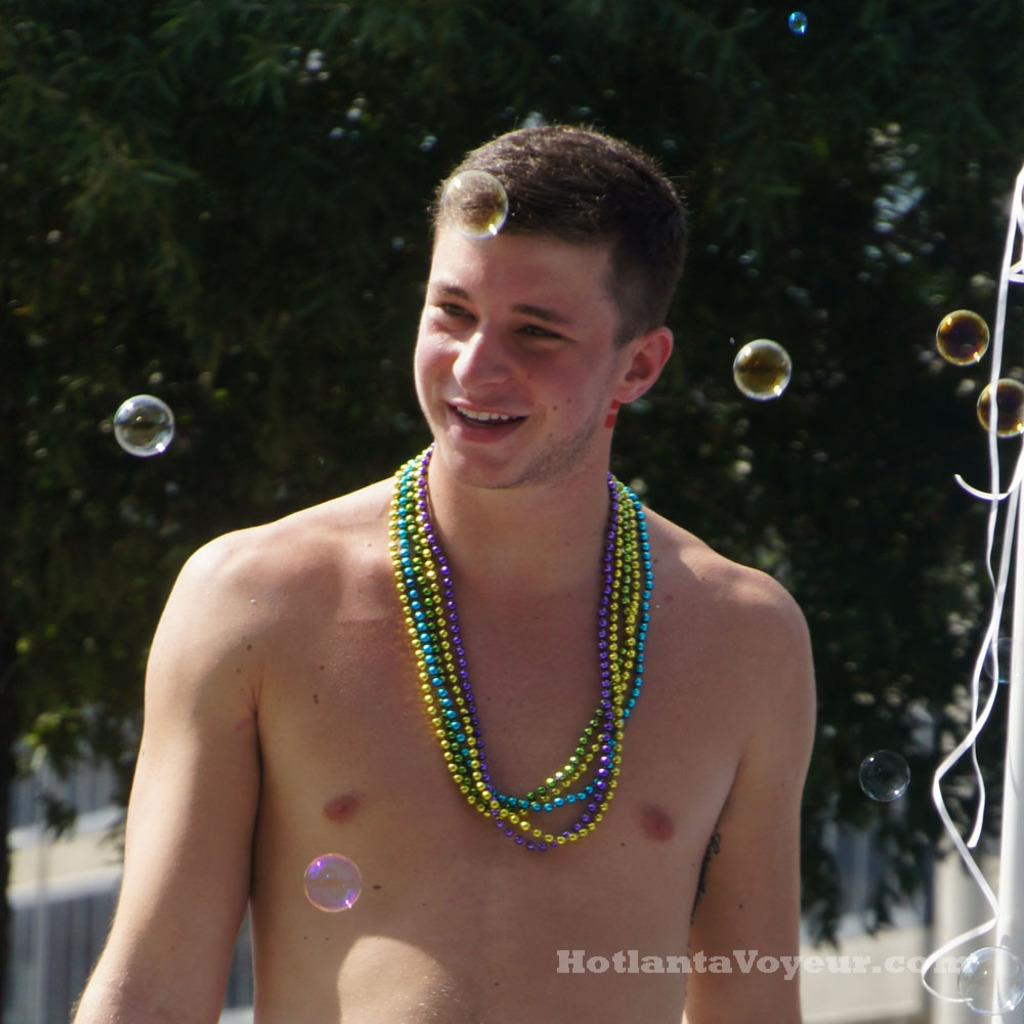Who is present in the image? There is a man in the image. What is the man doing in the image? The man is smiling in the image. What is the man wearing in the image? The man is wearing a pearl necklace in the image. What can be seen in the background of the image? There are trees visible in the background of the image. What is present in the bottom right corner of the image? There is a watermark in the bottom right corner of the image. Can you see a goat crossing the bridge in the image? There is no goat or bridge present in the image. What is the position of the sun in the image? The sun is not visible in the image, so its position cannot be determined. 